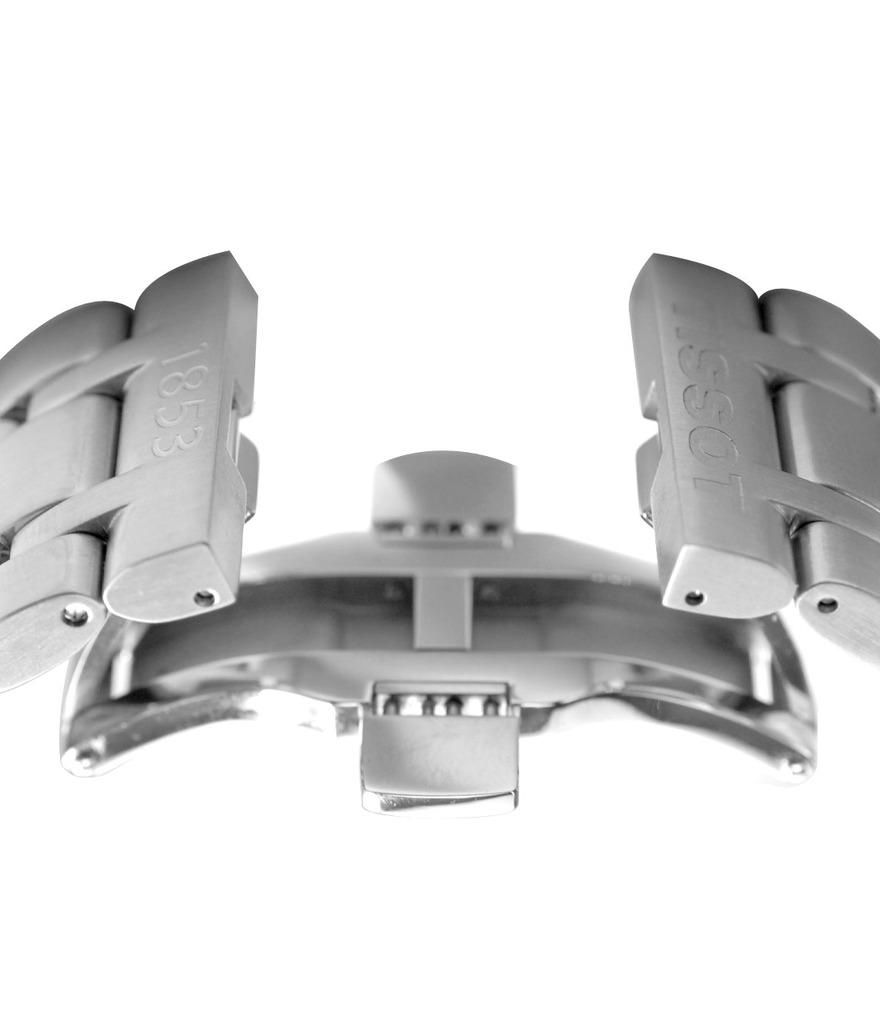What can be seen in the image? There is an object in the image. What is written on the object? The object has text on it. Are there any numbers on the object? Yes, the object has number digits on it. What is the color of the background in the image? The remaining portion of the image is in white color. What suggestion does the team make in the image? There is no team or suggestion present in the image; it only features an object with text and number digits on a white background. 